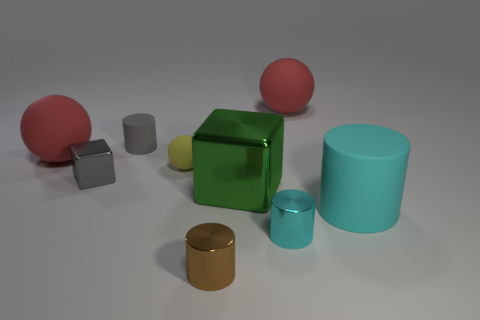Subtract all cubes. How many objects are left? 7 Subtract 0 purple spheres. How many objects are left? 9 Subtract all large purple shiny things. Subtract all yellow matte objects. How many objects are left? 8 Add 8 large red things. How many large red things are left? 10 Add 8 small cyan objects. How many small cyan objects exist? 9 